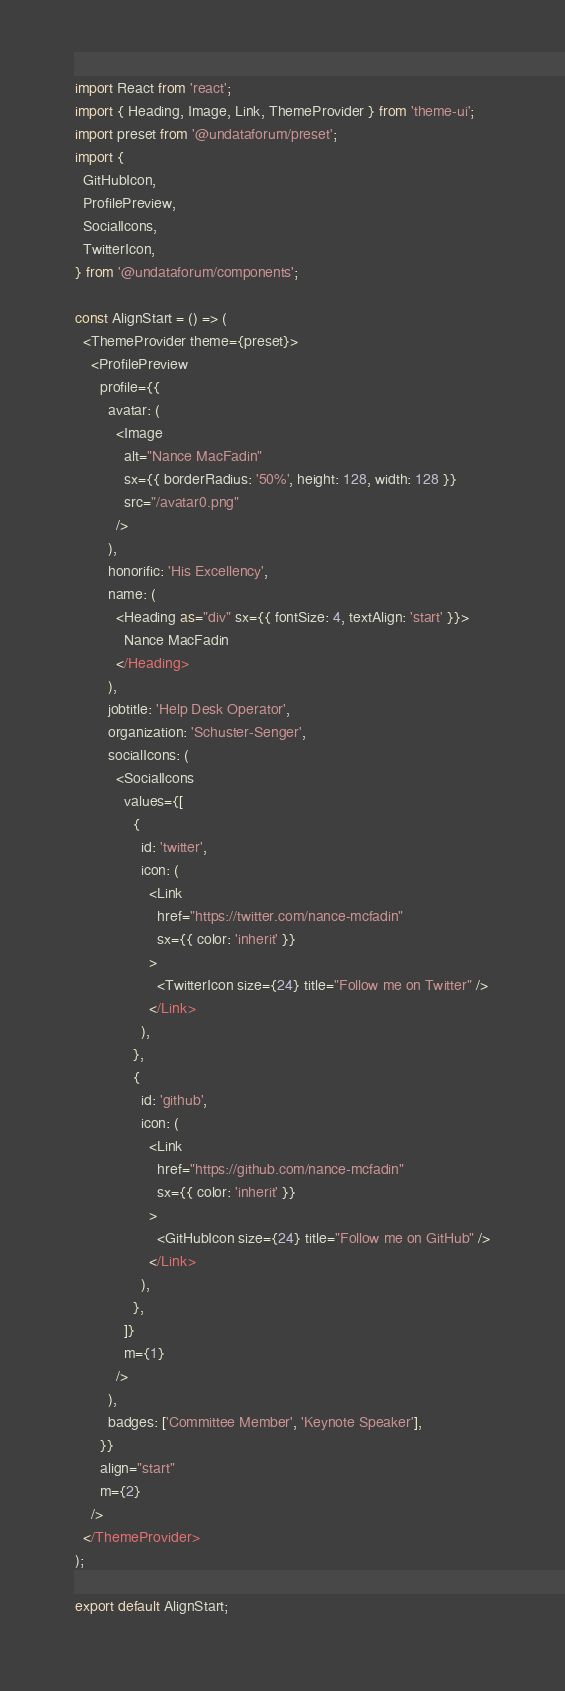<code> <loc_0><loc_0><loc_500><loc_500><_JavaScript_>import React from 'react';
import { Heading, Image, Link, ThemeProvider } from 'theme-ui';
import preset from '@undataforum/preset';
import {
  GitHubIcon,
  ProfilePreview,
  SocialIcons,
  TwitterIcon,
} from '@undataforum/components';

const AlignStart = () => (
  <ThemeProvider theme={preset}>
    <ProfilePreview
      profile={{
        avatar: (
          <Image
            alt="Nance MacFadin"
            sx={{ borderRadius: '50%', height: 128, width: 128 }}
            src="/avatar0.png"
          />
        ),
        honorific: 'His Excellency',
        name: (
          <Heading as="div" sx={{ fontSize: 4, textAlign: 'start' }}>
            Nance MacFadin
          </Heading>
        ),
        jobtitle: 'Help Desk Operator',
        organization: 'Schuster-Senger',
        socialIcons: (
          <SocialIcons
            values={[
              {
                id: 'twitter',
                icon: (
                  <Link
                    href="https://twitter.com/nance-mcfadin"
                    sx={{ color: 'inherit' }}
                  >
                    <TwitterIcon size={24} title="Follow me on Twitter" />
                  </Link>
                ),
              },
              {
                id: 'github',
                icon: (
                  <Link
                    href="https://github.com/nance-mcfadin"
                    sx={{ color: 'inherit' }}
                  >
                    <GitHubIcon size={24} title="Follow me on GitHub" />
                  </Link>
                ),
              },
            ]}
            m={1}
          />
        ),
        badges: ['Committee Member', 'Keynote Speaker'],
      }}
      align="start"
      m={2}
    />
  </ThemeProvider>
);

export default AlignStart;
</code> 